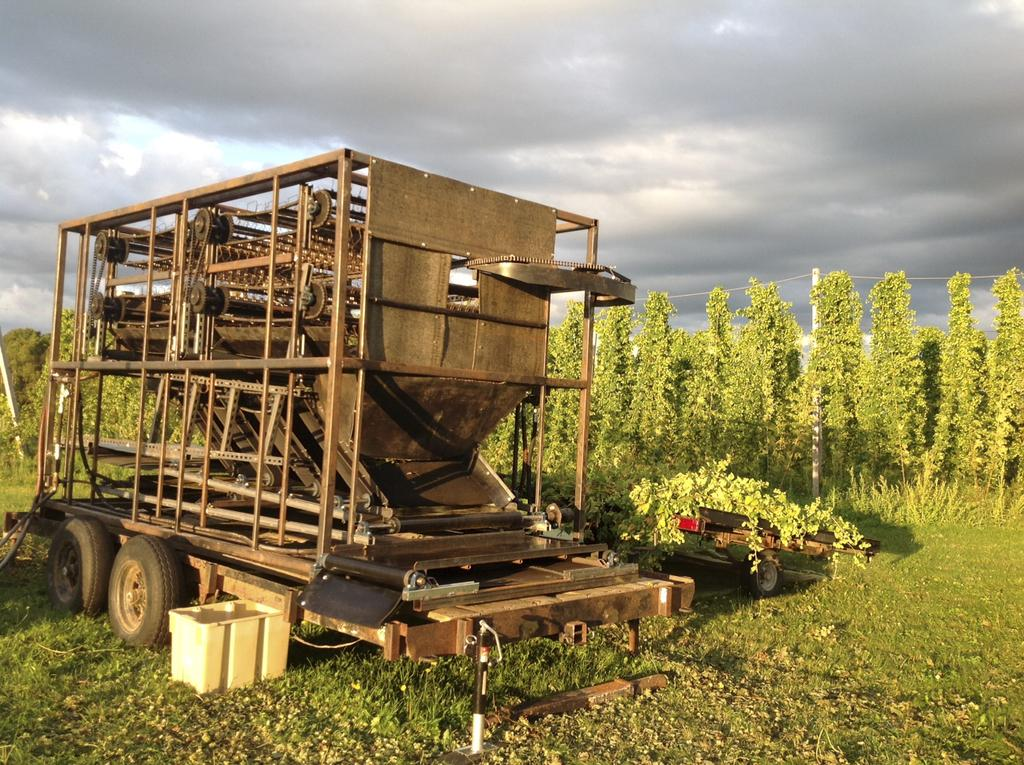What is located on the grass in the image? There is a vehicle and a cart on the grass in the image. What can be seen in the background of the image? There are trees, a pole with wires, and the sky visible in the background of the image. What type of pen can be seen in the image? There is no pen present in the image. What flavor of cream is being used in the image? There is no cream present in the image. 